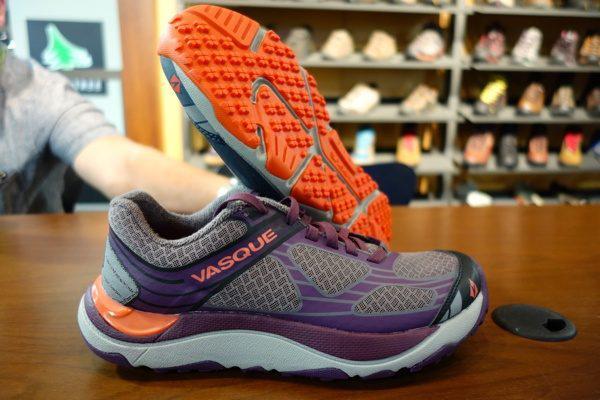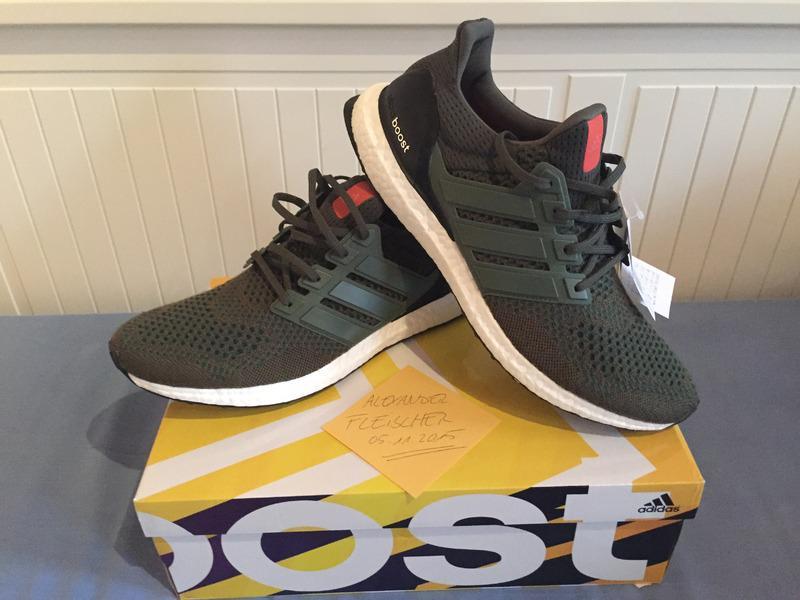The first image is the image on the left, the second image is the image on the right. For the images displayed, is the sentence "An image shows a pair of black sneakers posed on a shoe box." factually correct? Answer yes or no. Yes. The first image is the image on the left, the second image is the image on the right. Given the left and right images, does the statement "There is a black pair of sneakers sitting on a shoe box in the image on the right." hold true? Answer yes or no. Yes. 